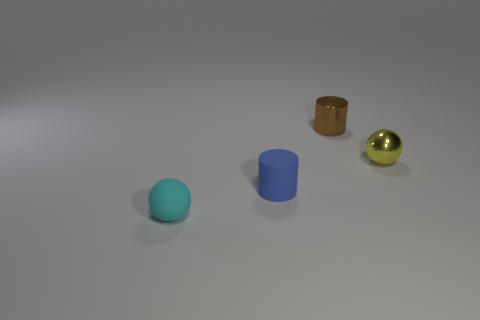What number of objects are either matte objects that are left of the blue object or metal spheres?
Make the answer very short. 2. Are any metallic cylinders visible?
Give a very brief answer. Yes. There is a tiny ball to the right of the tiny metallic cylinder; what material is it?
Offer a very short reply. Metal. What number of small objects are either cyan balls or purple rubber blocks?
Your answer should be very brief. 1. What is the color of the tiny rubber ball?
Your answer should be very brief. Cyan. There is a matte object that is on the right side of the tiny cyan matte object; is there a small ball that is in front of it?
Offer a very short reply. Yes. Is the number of cyan rubber objects on the left side of the cyan thing less than the number of tiny brown cylinders?
Offer a terse response. Yes. Are the sphere that is behind the cyan thing and the brown thing made of the same material?
Give a very brief answer. Yes. There is a object that is the same material as the tiny brown cylinder; what color is it?
Offer a very short reply. Yellow. Are there fewer small blue matte cylinders behind the yellow object than cylinders that are on the left side of the brown cylinder?
Offer a very short reply. Yes. 